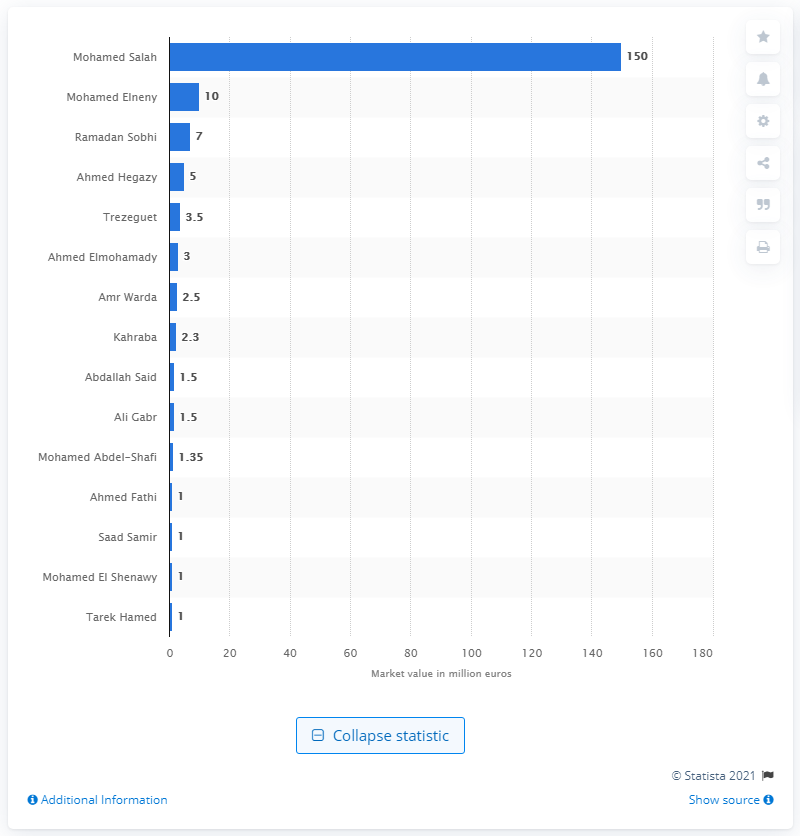Highlight a few significant elements in this photo. The market value of Mohamed Salah was 150... The most valuable player at the 2018 FIFA World Cup was Mohamed Salah. 